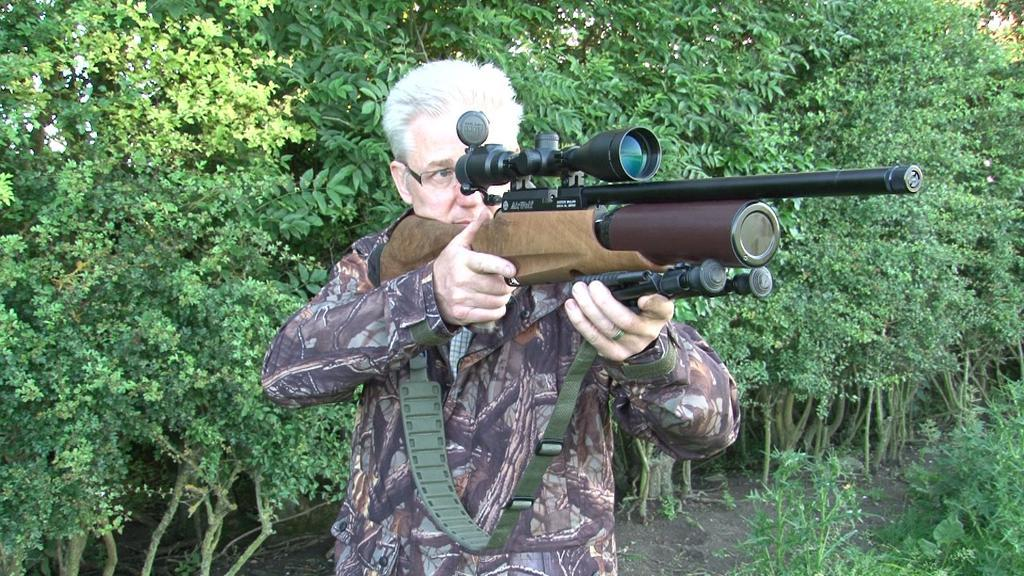Who is present in the image? There is a man in the image. What is the man doing in the image? The man is standing in the image. What object is the man holding in his hand? The man is holding a gun in his hand. What can be seen in the background of the image? There are trees behind the man. What type of toothpaste is the man using in the image? There is no toothpaste present in the image; the man is holding a gun. What experience does the man have with mountain climbing in the image? There is no mention of mountains or mountain climbing in the image; the man is standing with a gun in his hand. 